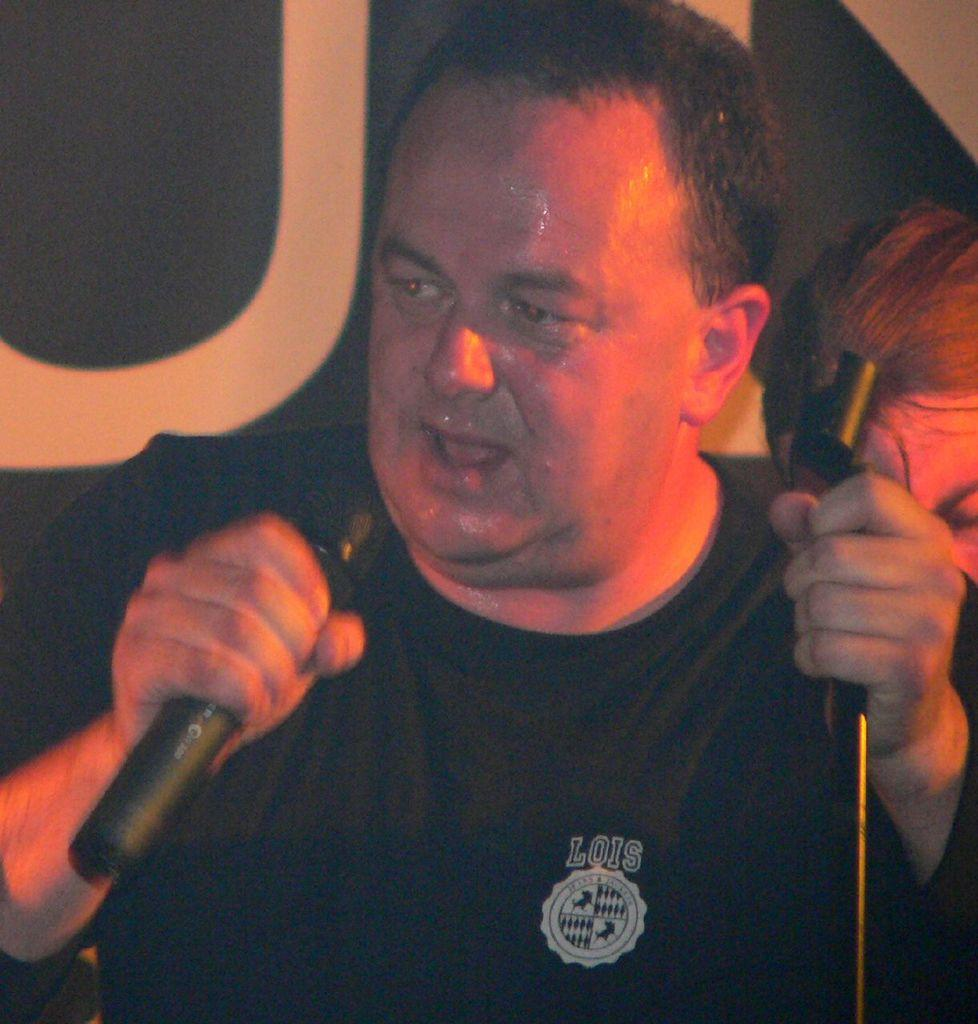What is the main subject of the image? There is a man in the image. What is the man holding in the image? The man is holding a mic. What type of joke is the man telling in the image? There is no joke being told in the image; the man is simply holding a mic. Can you see the man's elbow in the image? The elbow is not mentioned in the provided facts, so we cannot definitively say whether it is visible or not. However, it is likely that the man's elbow is not the focus of the image, as the main subject is the man holding a mic. 